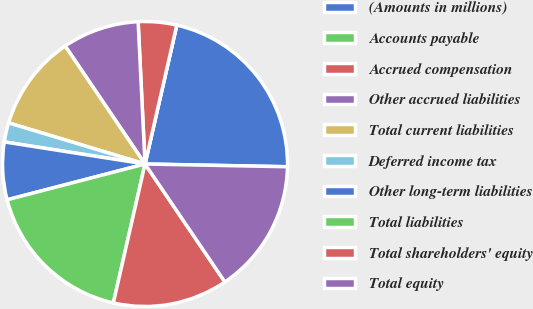Convert chart. <chart><loc_0><loc_0><loc_500><loc_500><pie_chart><fcel>(Amounts in millions)<fcel>Accounts payable<fcel>Accrued compensation<fcel>Other accrued liabilities<fcel>Total current liabilities<fcel>Deferred income tax<fcel>Other long-term liabilities<fcel>Total liabilities<fcel>Total shareholders' equity<fcel>Total equity<nl><fcel>21.73%<fcel>0.0%<fcel>4.35%<fcel>8.7%<fcel>10.87%<fcel>2.18%<fcel>6.52%<fcel>17.39%<fcel>13.04%<fcel>15.22%<nl></chart> 